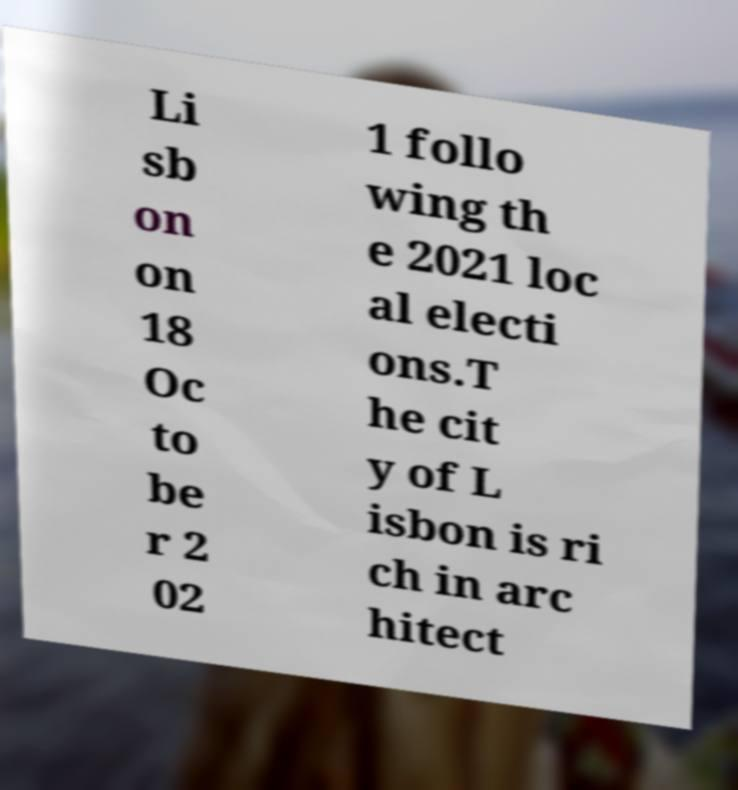What messages or text are displayed in this image? I need them in a readable, typed format. Li sb on on 18 Oc to be r 2 02 1 follo wing th e 2021 loc al electi ons.T he cit y of L isbon is ri ch in arc hitect 